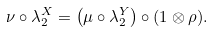Convert formula to latex. <formula><loc_0><loc_0><loc_500><loc_500>\nu \circ \lambda _ { 2 } ^ { X } = \left ( \mu \circ \lambda _ { 2 } ^ { Y } \right ) \circ ( 1 \otimes \rho ) .</formula> 